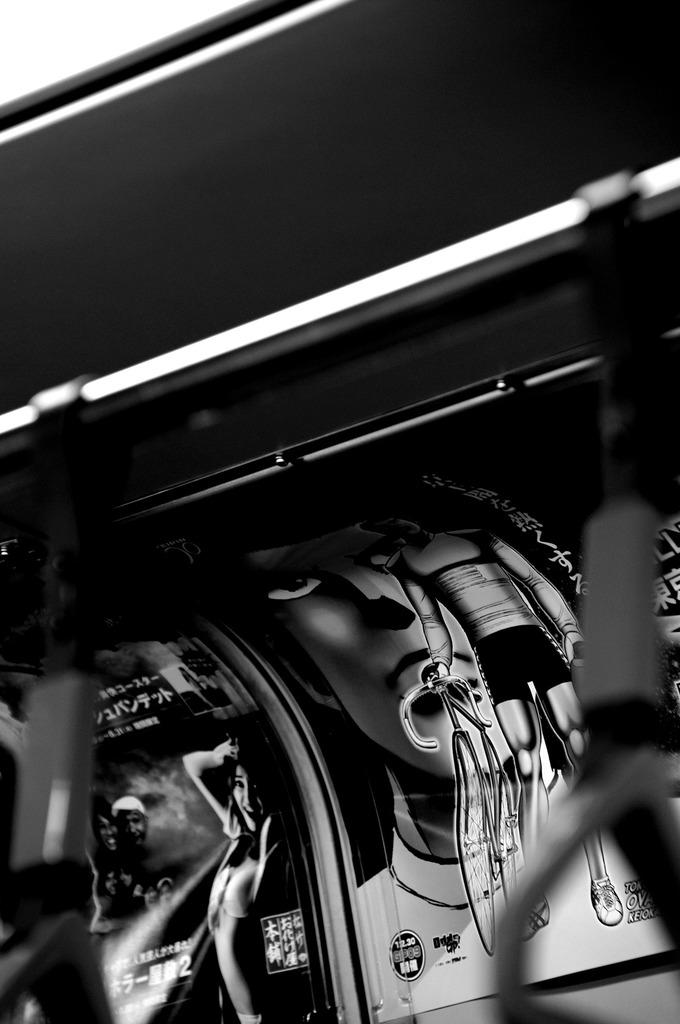What is the main object in the image? There is a rod in the image. What can be seen in the background of the image? There are posts visible in the background of the image. What news is the monkey reading from the rod in the image? There is no monkey or news present in the image; it only features a rod and posts in the background. 